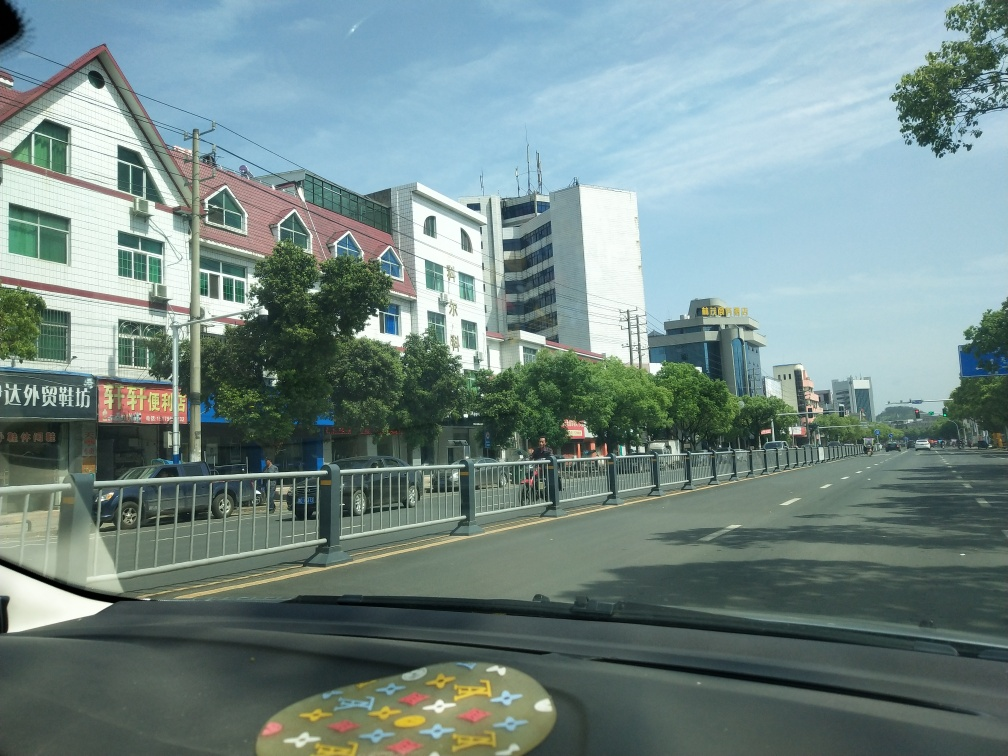This street seems pretty quiet. Could you infer what time of day it might be or why it's this uncrowded? While the specific time of day cannot be precisely determined from the image alone, several clues suggest that it might be during a period of low activity, such as mid-morning or early afternoon, when the rush hours of morning and evening commutes have passed. The shadows cast by the trees and buildings suggest it is not high noon, and the clear, sunny sky might indicate late morning or before the late afternoon. The uncrowded streets could be due to the time of day, day of the week, or it might be indicative of a quieter neighborhood. It's also possible that the photo could have been taken on a public holiday or during a time when people are less likely to be outdoors. 